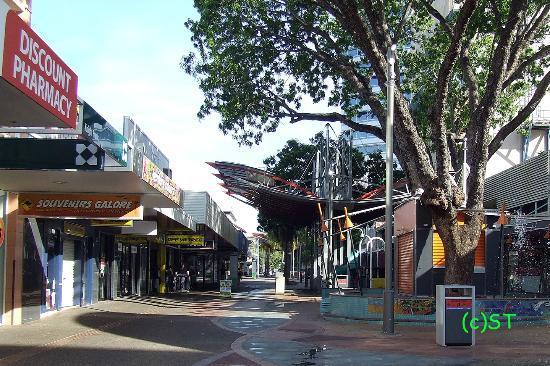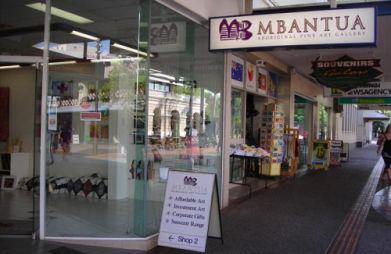The first image is the image on the left, the second image is the image on the right. Analyze the images presented: Is the assertion "At least one of the images includes a tree." valid? Answer yes or no. Yes. The first image is the image on the left, the second image is the image on the right. Considering the images on both sides, is "In the image on the left, at least 8 people are sitting at tables in the food court." valid? Answer yes or no. No. 